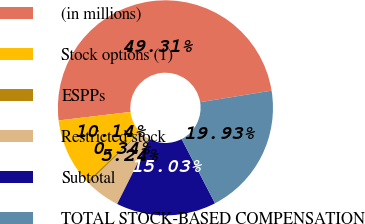Convert chart. <chart><loc_0><loc_0><loc_500><loc_500><pie_chart><fcel>(in millions)<fcel>Stock options (1)<fcel>ESPPs<fcel>Restricted stock<fcel>Subtotal<fcel>TOTAL STOCK-BASED COMPENSATION<nl><fcel>49.31%<fcel>10.14%<fcel>0.34%<fcel>5.24%<fcel>15.03%<fcel>19.93%<nl></chart> 